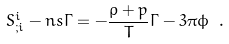<formula> <loc_0><loc_0><loc_500><loc_500>S ^ { i } _ { ; i } - n s \Gamma = - \frac { \rho + p } { T } \Gamma - 3 \pi \phi \ .</formula> 